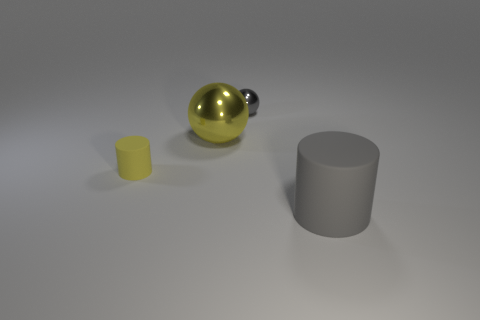How many other objects are the same color as the small shiny object?
Keep it short and to the point. 1. Does the matte thing to the left of the gray ball have the same shape as the large gray rubber object?
Ensure brevity in your answer.  Yes. Is the number of small yellow rubber cylinders that are on the right side of the gray shiny sphere less than the number of big objects?
Your response must be concise. Yes. Are there any big green blocks that have the same material as the tiny gray ball?
Your response must be concise. No. What material is the cylinder that is the same size as the yellow metal thing?
Offer a terse response. Rubber. Is the number of small gray metal balls that are on the left side of the gray metallic object less than the number of yellow spheres that are to the right of the large gray matte cylinder?
Offer a very short reply. No. There is a thing that is on the right side of the big yellow ball and behind the big gray thing; what is its shape?
Offer a very short reply. Sphere. What number of big gray things are the same shape as the tiny yellow object?
Ensure brevity in your answer.  1. There is a cylinder that is made of the same material as the large gray object; what is its size?
Offer a terse response. Small. Is the number of yellow metal objects greater than the number of big green metallic objects?
Provide a succinct answer. Yes. 